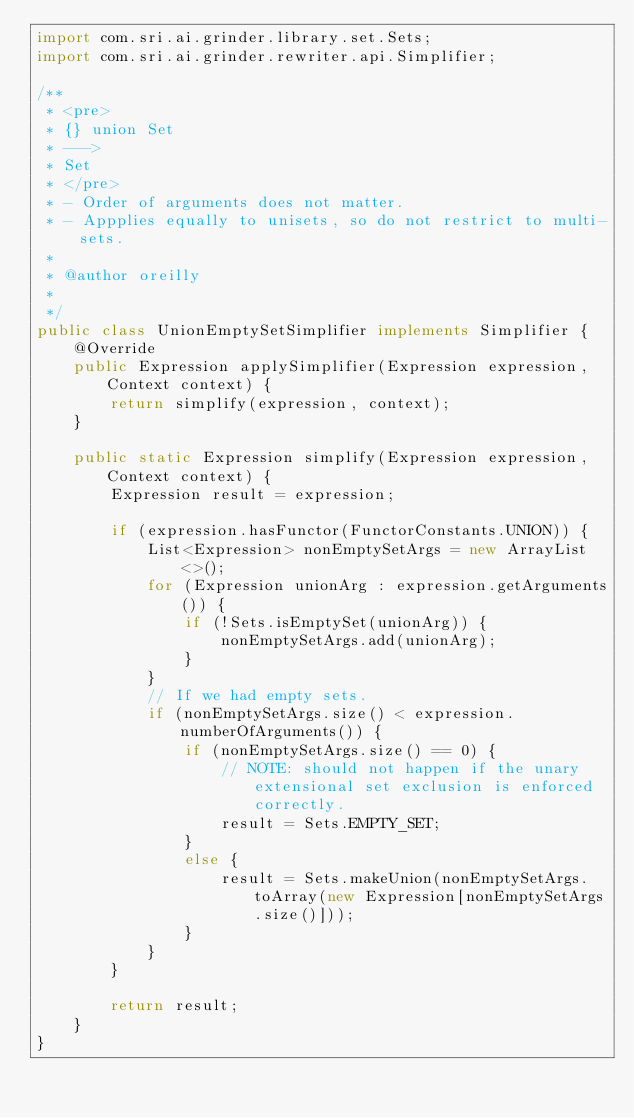<code> <loc_0><loc_0><loc_500><loc_500><_Java_>import com.sri.ai.grinder.library.set.Sets;
import com.sri.ai.grinder.rewriter.api.Simplifier;

/**
 * <pre>
 * {} union Set 
 * ---> 
 * Set
 * </pre>
 * - Order of arguments does not matter.
 * - Appplies equally to unisets, so do not restrict to multi-sets.
 *  
 * @author oreilly
 *
 */
public class UnionEmptySetSimplifier implements Simplifier {
	@Override
	public Expression applySimplifier(Expression expression, Context context) {
		return simplify(expression, context);
	}

	public static Expression simplify(Expression expression, Context context) {
		Expression result = expression;
		
		if (expression.hasFunctor(FunctorConstants.UNION)) {
			List<Expression> nonEmptySetArgs = new ArrayList<>();
			for (Expression unionArg : expression.getArguments()) {
				if (!Sets.isEmptySet(unionArg)) {
					nonEmptySetArgs.add(unionArg);
				}
			}
			// If we had empty sets.
			if (nonEmptySetArgs.size() < expression.numberOfArguments()) {
				if (nonEmptySetArgs.size() == 0) {
					// NOTE: should not happen if the unary extensional set exclusion is enforced correctly.
					result = Sets.EMPTY_SET; 
				}
				else {
					result = Sets.makeUnion(nonEmptySetArgs.toArray(new Expression[nonEmptySetArgs.size()]));
				}
			}
		}
		
		return result;
	}
}</code> 